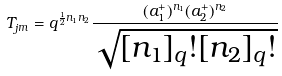Convert formula to latex. <formula><loc_0><loc_0><loc_500><loc_500>T _ { j m } = q ^ { \frac { 1 } { 2 } n _ { 1 } n _ { 2 } } \frac { ( a ^ { + } _ { 1 } ) ^ { n _ { 1 } } ( a ^ { + } _ { 2 } ) ^ { n _ { 2 } } } { \sqrt { [ n _ { 1 } ] _ { q } ! [ n _ { 2 } ] _ { q } ! } }</formula> 